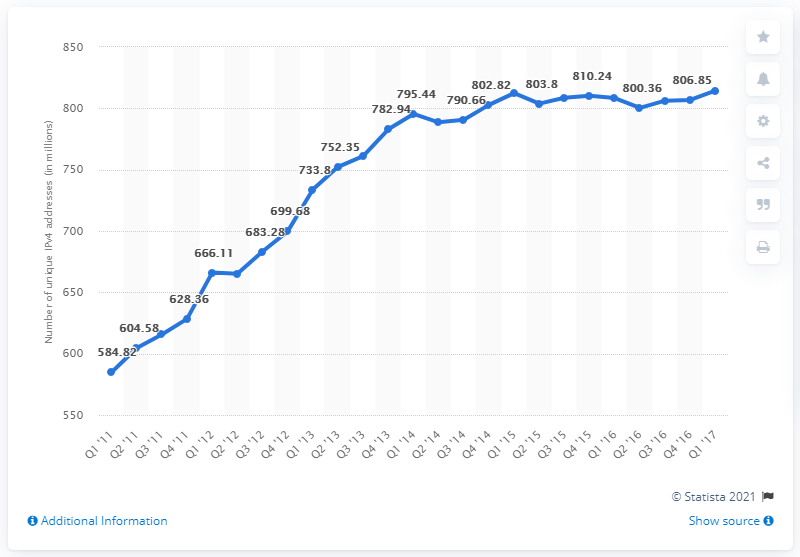Indicate a few pertinent items in this graphic. In the final quarter of 2017, there were approximately 814,430 IPv4 addresses available. In the quarter before 2017, there were approximately 814,430 IPv4 addresses. 